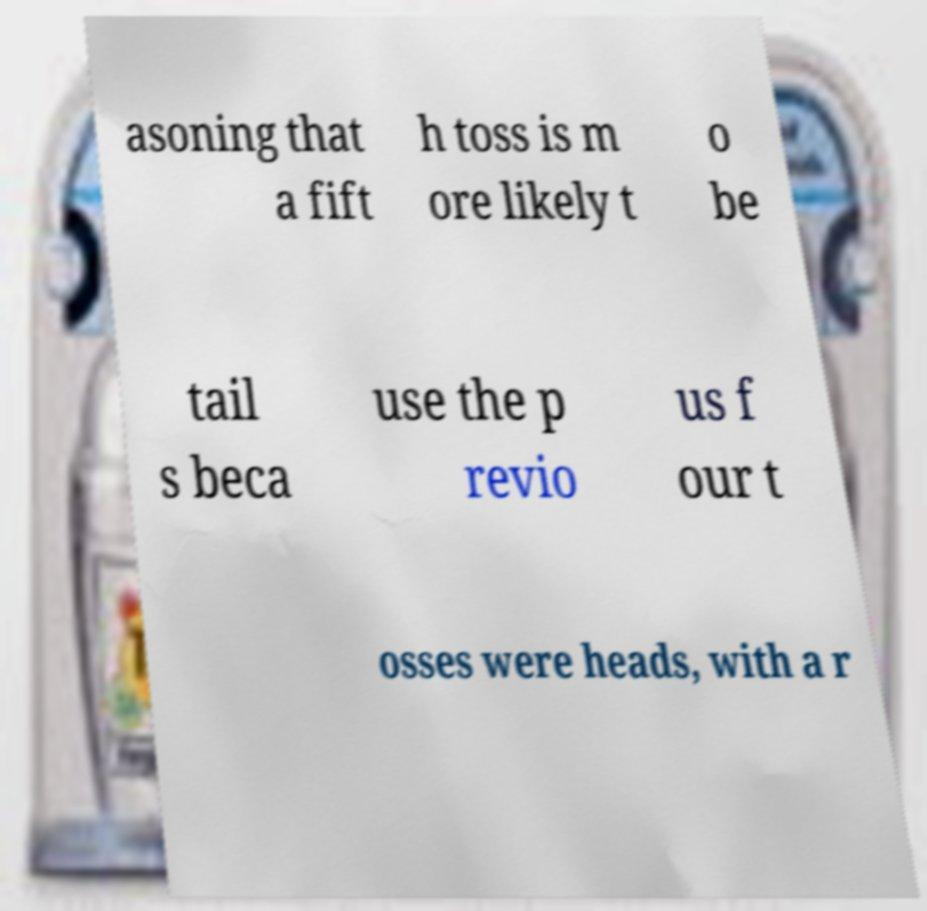For documentation purposes, I need the text within this image transcribed. Could you provide that? asoning that a fift h toss is m ore likely t o be tail s beca use the p revio us f our t osses were heads, with a r 